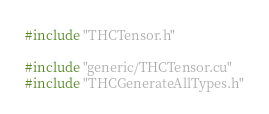Convert code to text. <code><loc_0><loc_0><loc_500><loc_500><_Cuda_>#include "THCTensor.h"

#include "generic/THCTensor.cu"
#include "THCGenerateAllTypes.h"
</code> 